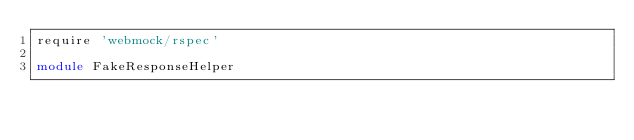Convert code to text. <code><loc_0><loc_0><loc_500><loc_500><_Ruby_>require 'webmock/rspec'

module FakeResponseHelper
</code> 